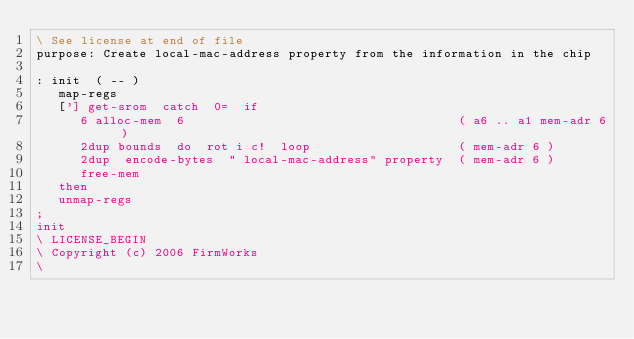Convert code to text. <code><loc_0><loc_0><loc_500><loc_500><_Forth_>\ See license at end of file
purpose: Create local-mac-address property from the information in the chip

: init  ( -- )
   map-regs
   ['] get-srom  catch  0=  if
      6 alloc-mem  6                                     ( a6 .. a1 mem-adr 6 )
      2dup bounds  do  rot i c!  loop                    ( mem-adr 6 )
      2dup  encode-bytes  " local-mac-address" property  ( mem-adr 6 )
      free-mem
   then
   unmap-regs
;
init
\ LICENSE_BEGIN
\ Copyright (c) 2006 FirmWorks
\ </code> 